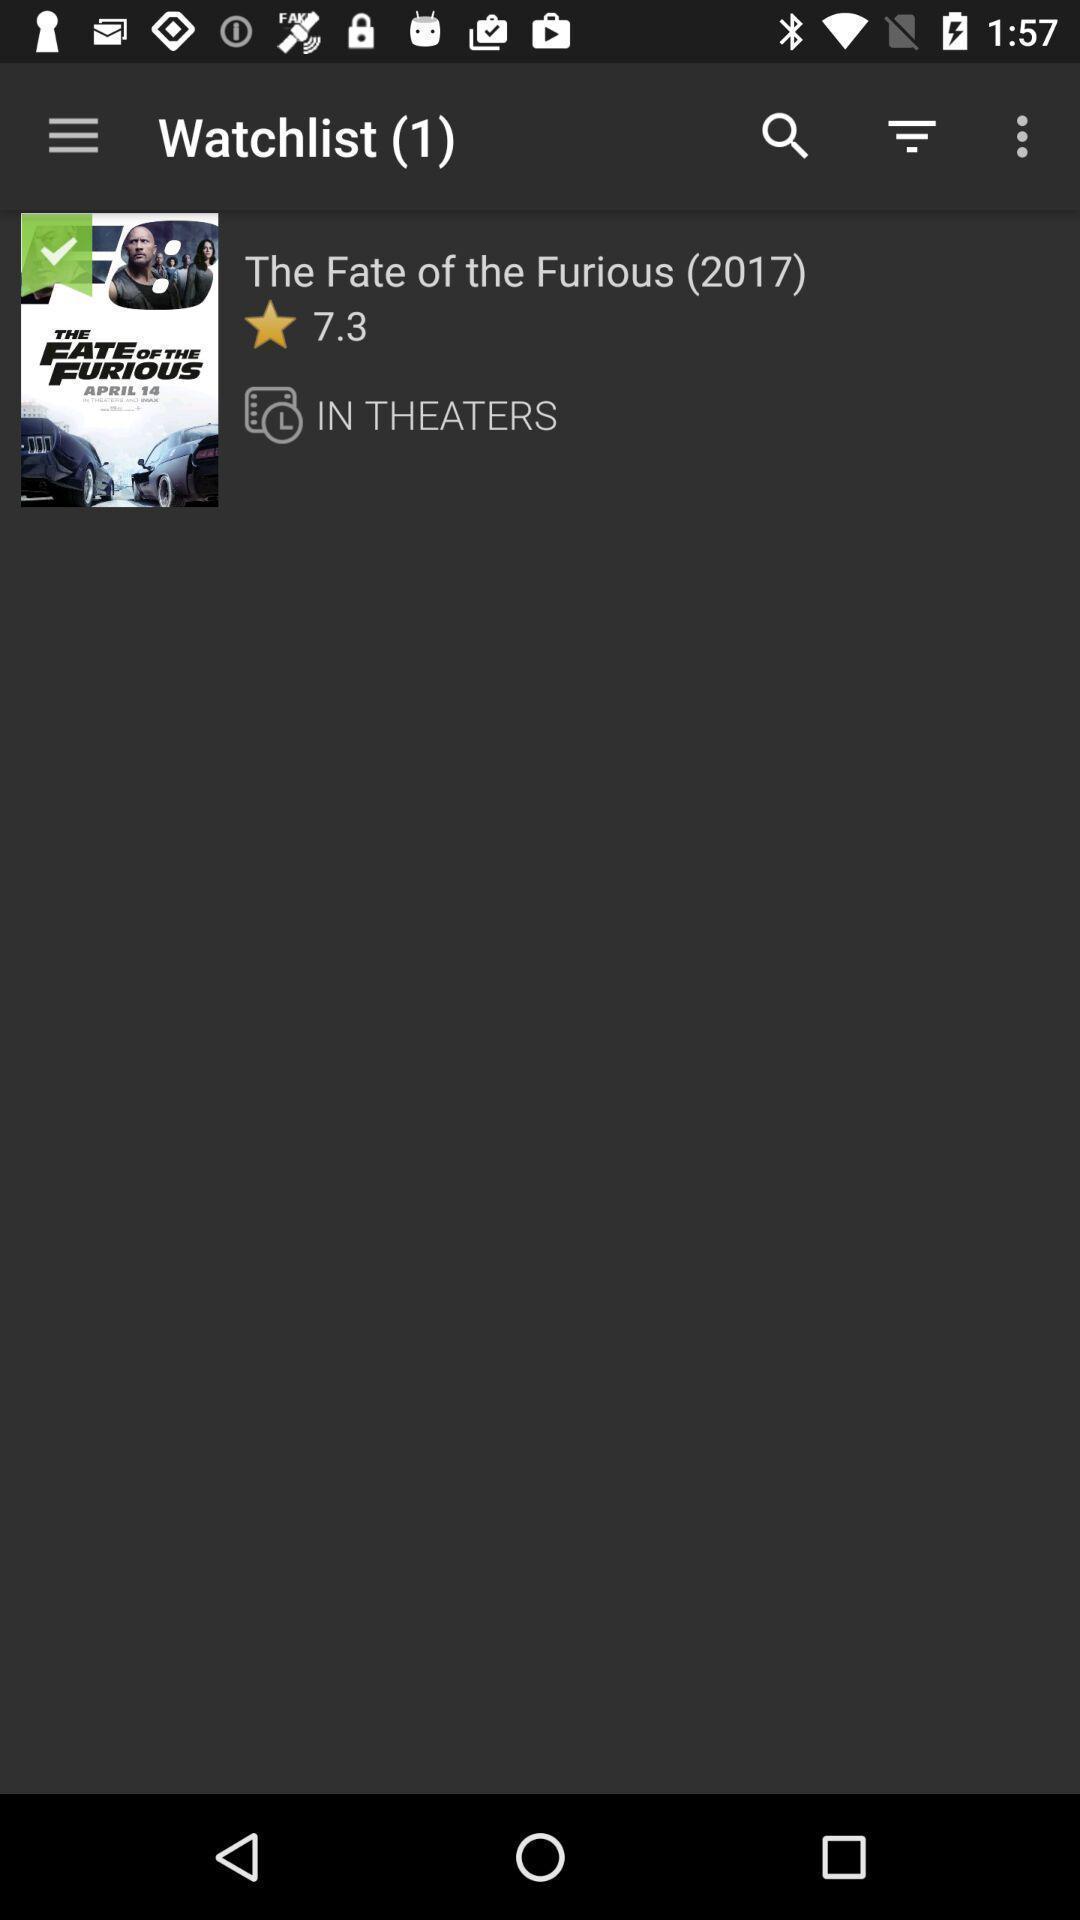Provide a description of this screenshot. Watch list in application with one movie in mobile. 